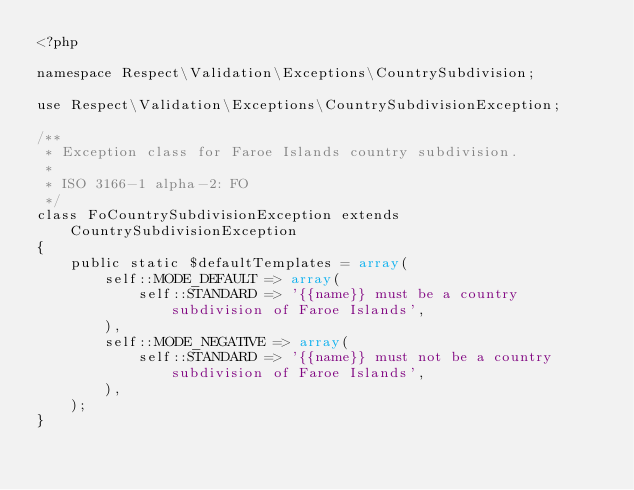Convert code to text. <code><loc_0><loc_0><loc_500><loc_500><_PHP_><?php

namespace Respect\Validation\Exceptions\CountrySubdivision;

use Respect\Validation\Exceptions\CountrySubdivisionException;

/**
 * Exception class for Faroe Islands country subdivision.
 *
 * ISO 3166-1 alpha-2: FO
 */
class FoCountrySubdivisionException extends CountrySubdivisionException
{
    public static $defaultTemplates = array(
        self::MODE_DEFAULT => array(
            self::STANDARD => '{{name}} must be a country subdivision of Faroe Islands',
        ),
        self::MODE_NEGATIVE => array(
            self::STANDARD => '{{name}} must not be a country subdivision of Faroe Islands',
        ),
    );
}
</code> 